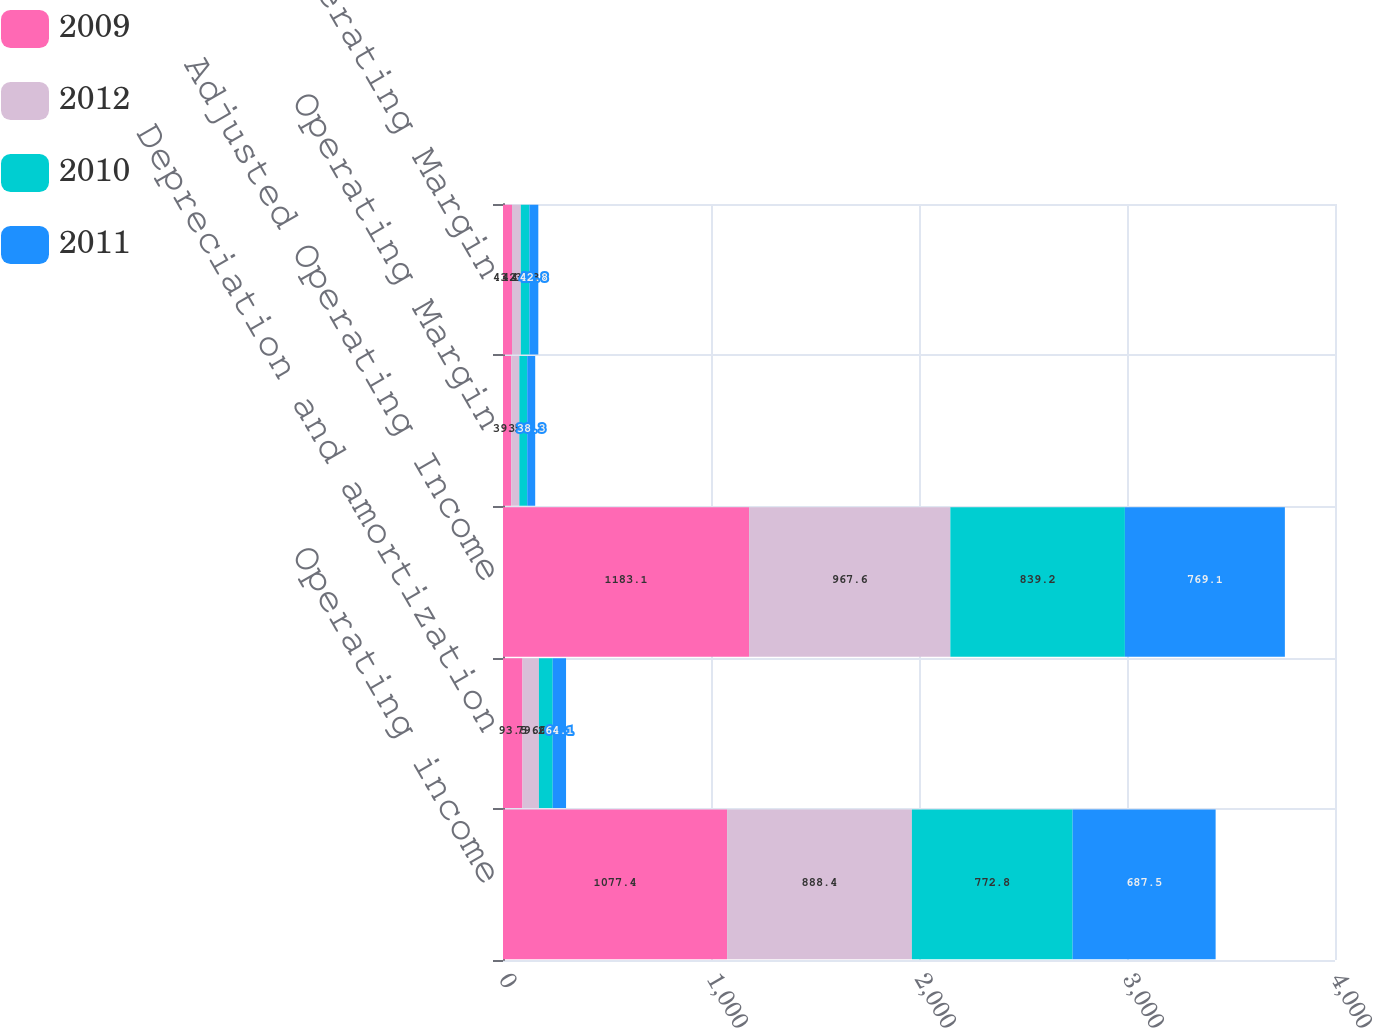Convert chart to OTSL. <chart><loc_0><loc_0><loc_500><loc_500><stacked_bar_chart><ecel><fcel>Operating income<fcel>Depreciation and amortization<fcel>Adjusted Operating Income<fcel>Operating Margin<fcel>Adjusted Operating Margin<nl><fcel>2009<fcel>1077.4<fcel>93.5<fcel>1183.1<fcel>39.5<fcel>43.3<nl><fcel>2012<fcel>888.4<fcel>79.2<fcel>967.6<fcel>39<fcel>42.4<nl><fcel>2010<fcel>772.8<fcel>66.3<fcel>839.2<fcel>38<fcel>41.3<nl><fcel>2011<fcel>687.5<fcel>64.1<fcel>769.1<fcel>38.3<fcel>42.8<nl></chart> 